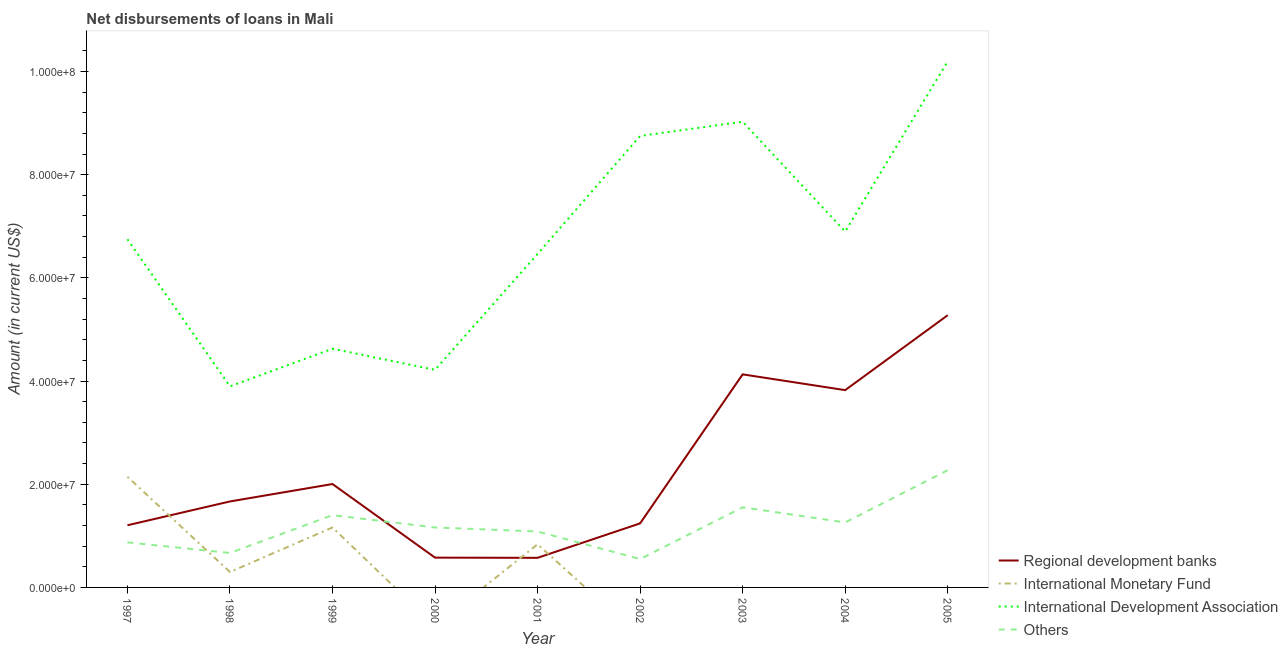How many different coloured lines are there?
Make the answer very short. 4. Does the line corresponding to amount of loan disimbursed by international monetary fund intersect with the line corresponding to amount of loan disimbursed by regional development banks?
Your response must be concise. Yes. What is the amount of loan disimbursed by regional development banks in 2001?
Offer a very short reply. 5.74e+06. Across all years, what is the maximum amount of loan disimbursed by other organisations?
Give a very brief answer. 2.27e+07. Across all years, what is the minimum amount of loan disimbursed by regional development banks?
Keep it short and to the point. 5.74e+06. What is the total amount of loan disimbursed by other organisations in the graph?
Ensure brevity in your answer.  1.08e+08. What is the difference between the amount of loan disimbursed by international development association in 2003 and that in 2004?
Your response must be concise. 2.13e+07. What is the difference between the amount of loan disimbursed by international monetary fund in 2000 and the amount of loan disimbursed by other organisations in 2003?
Offer a very short reply. -1.55e+07. What is the average amount of loan disimbursed by international monetary fund per year?
Offer a very short reply. 4.94e+06. In the year 1999, what is the difference between the amount of loan disimbursed by international monetary fund and amount of loan disimbursed by international development association?
Provide a succinct answer. -3.46e+07. In how many years, is the amount of loan disimbursed by international development association greater than 32000000 US$?
Make the answer very short. 9. What is the ratio of the amount of loan disimbursed by international monetary fund in 1999 to that in 2001?
Your response must be concise. 1.39. What is the difference between the highest and the second highest amount of loan disimbursed by regional development banks?
Provide a short and direct response. 1.15e+07. What is the difference between the highest and the lowest amount of loan disimbursed by regional development banks?
Your answer should be compact. 4.70e+07. Is it the case that in every year, the sum of the amount of loan disimbursed by international monetary fund and amount of loan disimbursed by regional development banks is greater than the sum of amount of loan disimbursed by international development association and amount of loan disimbursed by other organisations?
Your response must be concise. No. Is the amount of loan disimbursed by international development association strictly greater than the amount of loan disimbursed by regional development banks over the years?
Make the answer very short. Yes. How many lines are there?
Give a very brief answer. 4. How many years are there in the graph?
Keep it short and to the point. 9. Are the values on the major ticks of Y-axis written in scientific E-notation?
Offer a very short reply. Yes. Does the graph contain any zero values?
Your answer should be compact. Yes. Does the graph contain grids?
Ensure brevity in your answer.  No. Where does the legend appear in the graph?
Offer a very short reply. Bottom right. What is the title of the graph?
Your answer should be very brief. Net disbursements of loans in Mali. Does "Source data assessment" appear as one of the legend labels in the graph?
Give a very brief answer. No. What is the Amount (in current US$) in Regional development banks in 1997?
Ensure brevity in your answer.  1.21e+07. What is the Amount (in current US$) of International Monetary Fund in 1997?
Offer a terse response. 2.15e+07. What is the Amount (in current US$) in International Development Association in 1997?
Your answer should be very brief. 6.75e+07. What is the Amount (in current US$) of Others in 1997?
Provide a succinct answer. 8.74e+06. What is the Amount (in current US$) of Regional development banks in 1998?
Keep it short and to the point. 1.67e+07. What is the Amount (in current US$) of International Monetary Fund in 1998?
Provide a succinct answer. 2.99e+06. What is the Amount (in current US$) in International Development Association in 1998?
Your answer should be compact. 3.90e+07. What is the Amount (in current US$) in Others in 1998?
Offer a terse response. 6.68e+06. What is the Amount (in current US$) in Regional development banks in 1999?
Offer a very short reply. 2.00e+07. What is the Amount (in current US$) in International Monetary Fund in 1999?
Provide a short and direct response. 1.16e+07. What is the Amount (in current US$) of International Development Association in 1999?
Keep it short and to the point. 4.63e+07. What is the Amount (in current US$) of Others in 1999?
Offer a terse response. 1.40e+07. What is the Amount (in current US$) in Regional development banks in 2000?
Provide a short and direct response. 5.78e+06. What is the Amount (in current US$) of International Monetary Fund in 2000?
Offer a very short reply. 0. What is the Amount (in current US$) in International Development Association in 2000?
Make the answer very short. 4.22e+07. What is the Amount (in current US$) of Others in 2000?
Your response must be concise. 1.16e+07. What is the Amount (in current US$) in Regional development banks in 2001?
Make the answer very short. 5.74e+06. What is the Amount (in current US$) in International Monetary Fund in 2001?
Your response must be concise. 8.37e+06. What is the Amount (in current US$) of International Development Association in 2001?
Your response must be concise. 6.46e+07. What is the Amount (in current US$) in Others in 2001?
Provide a succinct answer. 1.08e+07. What is the Amount (in current US$) in Regional development banks in 2002?
Your answer should be compact. 1.24e+07. What is the Amount (in current US$) of International Monetary Fund in 2002?
Give a very brief answer. 0. What is the Amount (in current US$) of International Development Association in 2002?
Provide a short and direct response. 8.75e+07. What is the Amount (in current US$) in Others in 2002?
Your answer should be very brief. 5.50e+06. What is the Amount (in current US$) of Regional development banks in 2003?
Ensure brevity in your answer.  4.13e+07. What is the Amount (in current US$) of International Development Association in 2003?
Provide a short and direct response. 9.03e+07. What is the Amount (in current US$) of Others in 2003?
Offer a terse response. 1.55e+07. What is the Amount (in current US$) in Regional development banks in 2004?
Give a very brief answer. 3.82e+07. What is the Amount (in current US$) of International Monetary Fund in 2004?
Offer a terse response. 0. What is the Amount (in current US$) of International Development Association in 2004?
Your answer should be compact. 6.90e+07. What is the Amount (in current US$) of Others in 2004?
Provide a short and direct response. 1.26e+07. What is the Amount (in current US$) of Regional development banks in 2005?
Keep it short and to the point. 5.28e+07. What is the Amount (in current US$) in International Monetary Fund in 2005?
Offer a terse response. 0. What is the Amount (in current US$) in International Development Association in 2005?
Your answer should be compact. 1.02e+08. What is the Amount (in current US$) in Others in 2005?
Your response must be concise. 2.27e+07. Across all years, what is the maximum Amount (in current US$) of Regional development banks?
Your response must be concise. 5.28e+07. Across all years, what is the maximum Amount (in current US$) of International Monetary Fund?
Ensure brevity in your answer.  2.15e+07. Across all years, what is the maximum Amount (in current US$) of International Development Association?
Offer a terse response. 1.02e+08. Across all years, what is the maximum Amount (in current US$) of Others?
Your answer should be compact. 2.27e+07. Across all years, what is the minimum Amount (in current US$) of Regional development banks?
Keep it short and to the point. 5.74e+06. Across all years, what is the minimum Amount (in current US$) in International Monetary Fund?
Your answer should be compact. 0. Across all years, what is the minimum Amount (in current US$) in International Development Association?
Make the answer very short. 3.90e+07. Across all years, what is the minimum Amount (in current US$) in Others?
Your response must be concise. 5.50e+06. What is the total Amount (in current US$) of Regional development banks in the graph?
Your response must be concise. 2.05e+08. What is the total Amount (in current US$) of International Monetary Fund in the graph?
Provide a succinct answer. 4.44e+07. What is the total Amount (in current US$) in International Development Association in the graph?
Provide a succinct answer. 6.08e+08. What is the total Amount (in current US$) in Others in the graph?
Ensure brevity in your answer.  1.08e+08. What is the difference between the Amount (in current US$) of Regional development banks in 1997 and that in 1998?
Ensure brevity in your answer.  -4.61e+06. What is the difference between the Amount (in current US$) of International Monetary Fund in 1997 and that in 1998?
Your answer should be very brief. 1.85e+07. What is the difference between the Amount (in current US$) in International Development Association in 1997 and that in 1998?
Offer a terse response. 2.85e+07. What is the difference between the Amount (in current US$) in Others in 1997 and that in 1998?
Your response must be concise. 2.06e+06. What is the difference between the Amount (in current US$) in Regional development banks in 1997 and that in 1999?
Your answer should be compact. -7.99e+06. What is the difference between the Amount (in current US$) in International Monetary Fund in 1997 and that in 1999?
Make the answer very short. 9.83e+06. What is the difference between the Amount (in current US$) of International Development Association in 1997 and that in 1999?
Keep it short and to the point. 2.12e+07. What is the difference between the Amount (in current US$) in Others in 1997 and that in 1999?
Offer a terse response. -5.27e+06. What is the difference between the Amount (in current US$) of Regional development banks in 1997 and that in 2000?
Give a very brief answer. 6.28e+06. What is the difference between the Amount (in current US$) in International Development Association in 1997 and that in 2000?
Your response must be concise. 2.53e+07. What is the difference between the Amount (in current US$) of Others in 1997 and that in 2000?
Offer a terse response. -2.88e+06. What is the difference between the Amount (in current US$) of Regional development banks in 1997 and that in 2001?
Provide a succinct answer. 6.32e+06. What is the difference between the Amount (in current US$) of International Monetary Fund in 1997 and that in 2001?
Provide a succinct answer. 1.31e+07. What is the difference between the Amount (in current US$) of International Development Association in 1997 and that in 2001?
Provide a short and direct response. 2.84e+06. What is the difference between the Amount (in current US$) of Others in 1997 and that in 2001?
Make the answer very short. -2.10e+06. What is the difference between the Amount (in current US$) of Regional development banks in 1997 and that in 2002?
Provide a succinct answer. -3.63e+05. What is the difference between the Amount (in current US$) in International Development Association in 1997 and that in 2002?
Your response must be concise. -2.00e+07. What is the difference between the Amount (in current US$) in Others in 1997 and that in 2002?
Keep it short and to the point. 3.24e+06. What is the difference between the Amount (in current US$) in Regional development banks in 1997 and that in 2003?
Ensure brevity in your answer.  -2.93e+07. What is the difference between the Amount (in current US$) of International Development Association in 1997 and that in 2003?
Offer a terse response. -2.28e+07. What is the difference between the Amount (in current US$) of Others in 1997 and that in 2003?
Provide a short and direct response. -6.79e+06. What is the difference between the Amount (in current US$) in Regional development banks in 1997 and that in 2004?
Provide a succinct answer. -2.62e+07. What is the difference between the Amount (in current US$) of International Development Association in 1997 and that in 2004?
Offer a very short reply. -1.50e+06. What is the difference between the Amount (in current US$) of Others in 1997 and that in 2004?
Offer a terse response. -3.86e+06. What is the difference between the Amount (in current US$) of Regional development banks in 1997 and that in 2005?
Make the answer very short. -4.07e+07. What is the difference between the Amount (in current US$) of International Development Association in 1997 and that in 2005?
Give a very brief answer. -3.45e+07. What is the difference between the Amount (in current US$) in Others in 1997 and that in 2005?
Keep it short and to the point. -1.40e+07. What is the difference between the Amount (in current US$) in Regional development banks in 1998 and that in 1999?
Provide a succinct answer. -3.38e+06. What is the difference between the Amount (in current US$) in International Monetary Fund in 1998 and that in 1999?
Keep it short and to the point. -8.63e+06. What is the difference between the Amount (in current US$) of International Development Association in 1998 and that in 1999?
Make the answer very short. -7.29e+06. What is the difference between the Amount (in current US$) in Others in 1998 and that in 1999?
Your answer should be very brief. -7.33e+06. What is the difference between the Amount (in current US$) in Regional development banks in 1998 and that in 2000?
Your answer should be very brief. 1.09e+07. What is the difference between the Amount (in current US$) of International Development Association in 1998 and that in 2000?
Offer a terse response. -3.20e+06. What is the difference between the Amount (in current US$) of Others in 1998 and that in 2000?
Offer a terse response. -4.94e+06. What is the difference between the Amount (in current US$) in Regional development banks in 1998 and that in 2001?
Keep it short and to the point. 1.09e+07. What is the difference between the Amount (in current US$) in International Monetary Fund in 1998 and that in 2001?
Ensure brevity in your answer.  -5.37e+06. What is the difference between the Amount (in current US$) of International Development Association in 1998 and that in 2001?
Your answer should be very brief. -2.57e+07. What is the difference between the Amount (in current US$) of Others in 1998 and that in 2001?
Provide a succinct answer. -4.16e+06. What is the difference between the Amount (in current US$) of Regional development banks in 1998 and that in 2002?
Your answer should be very brief. 4.25e+06. What is the difference between the Amount (in current US$) in International Development Association in 1998 and that in 2002?
Offer a terse response. -4.85e+07. What is the difference between the Amount (in current US$) of Others in 1998 and that in 2002?
Give a very brief answer. 1.18e+06. What is the difference between the Amount (in current US$) of Regional development banks in 1998 and that in 2003?
Provide a short and direct response. -2.46e+07. What is the difference between the Amount (in current US$) in International Development Association in 1998 and that in 2003?
Offer a terse response. -5.13e+07. What is the difference between the Amount (in current US$) in Others in 1998 and that in 2003?
Provide a short and direct response. -8.85e+06. What is the difference between the Amount (in current US$) in Regional development banks in 1998 and that in 2004?
Ensure brevity in your answer.  -2.16e+07. What is the difference between the Amount (in current US$) in International Development Association in 1998 and that in 2004?
Offer a very short reply. -3.00e+07. What is the difference between the Amount (in current US$) of Others in 1998 and that in 2004?
Your response must be concise. -5.92e+06. What is the difference between the Amount (in current US$) in Regional development banks in 1998 and that in 2005?
Offer a terse response. -3.61e+07. What is the difference between the Amount (in current US$) in International Development Association in 1998 and that in 2005?
Your answer should be compact. -6.30e+07. What is the difference between the Amount (in current US$) in Others in 1998 and that in 2005?
Offer a very short reply. -1.60e+07. What is the difference between the Amount (in current US$) in Regional development banks in 1999 and that in 2000?
Your answer should be very brief. 1.43e+07. What is the difference between the Amount (in current US$) in International Development Association in 1999 and that in 2000?
Offer a very short reply. 4.10e+06. What is the difference between the Amount (in current US$) of Others in 1999 and that in 2000?
Make the answer very short. 2.39e+06. What is the difference between the Amount (in current US$) in Regional development banks in 1999 and that in 2001?
Give a very brief answer. 1.43e+07. What is the difference between the Amount (in current US$) of International Monetary Fund in 1999 and that in 2001?
Provide a short and direct response. 3.26e+06. What is the difference between the Amount (in current US$) of International Development Association in 1999 and that in 2001?
Make the answer very short. -1.84e+07. What is the difference between the Amount (in current US$) of Others in 1999 and that in 2001?
Provide a short and direct response. 3.17e+06. What is the difference between the Amount (in current US$) in Regional development banks in 1999 and that in 2002?
Give a very brief answer. 7.63e+06. What is the difference between the Amount (in current US$) in International Development Association in 1999 and that in 2002?
Your answer should be very brief. -4.12e+07. What is the difference between the Amount (in current US$) in Others in 1999 and that in 2002?
Provide a succinct answer. 8.51e+06. What is the difference between the Amount (in current US$) of Regional development banks in 1999 and that in 2003?
Your response must be concise. -2.13e+07. What is the difference between the Amount (in current US$) in International Development Association in 1999 and that in 2003?
Make the answer very short. -4.40e+07. What is the difference between the Amount (in current US$) in Others in 1999 and that in 2003?
Ensure brevity in your answer.  -1.52e+06. What is the difference between the Amount (in current US$) of Regional development banks in 1999 and that in 2004?
Offer a very short reply. -1.82e+07. What is the difference between the Amount (in current US$) in International Development Association in 1999 and that in 2004?
Give a very brief answer. -2.27e+07. What is the difference between the Amount (in current US$) of Others in 1999 and that in 2004?
Make the answer very short. 1.42e+06. What is the difference between the Amount (in current US$) of Regional development banks in 1999 and that in 2005?
Your answer should be very brief. -3.27e+07. What is the difference between the Amount (in current US$) in International Development Association in 1999 and that in 2005?
Make the answer very short. -5.57e+07. What is the difference between the Amount (in current US$) of Others in 1999 and that in 2005?
Your answer should be compact. -8.71e+06. What is the difference between the Amount (in current US$) in Regional development banks in 2000 and that in 2001?
Provide a short and direct response. 3.80e+04. What is the difference between the Amount (in current US$) in International Development Association in 2000 and that in 2001?
Provide a short and direct response. -2.25e+07. What is the difference between the Amount (in current US$) of Others in 2000 and that in 2001?
Make the answer very short. 7.78e+05. What is the difference between the Amount (in current US$) in Regional development banks in 2000 and that in 2002?
Make the answer very short. -6.64e+06. What is the difference between the Amount (in current US$) in International Development Association in 2000 and that in 2002?
Your answer should be compact. -4.53e+07. What is the difference between the Amount (in current US$) in Others in 2000 and that in 2002?
Ensure brevity in your answer.  6.12e+06. What is the difference between the Amount (in current US$) of Regional development banks in 2000 and that in 2003?
Your answer should be very brief. -3.55e+07. What is the difference between the Amount (in current US$) in International Development Association in 2000 and that in 2003?
Offer a very short reply. -4.81e+07. What is the difference between the Amount (in current US$) in Others in 2000 and that in 2003?
Offer a very short reply. -3.91e+06. What is the difference between the Amount (in current US$) in Regional development banks in 2000 and that in 2004?
Your answer should be compact. -3.25e+07. What is the difference between the Amount (in current US$) of International Development Association in 2000 and that in 2004?
Provide a succinct answer. -2.68e+07. What is the difference between the Amount (in current US$) of Others in 2000 and that in 2004?
Make the answer very short. -9.76e+05. What is the difference between the Amount (in current US$) in Regional development banks in 2000 and that in 2005?
Make the answer very short. -4.70e+07. What is the difference between the Amount (in current US$) in International Development Association in 2000 and that in 2005?
Ensure brevity in your answer.  -5.98e+07. What is the difference between the Amount (in current US$) in Others in 2000 and that in 2005?
Offer a terse response. -1.11e+07. What is the difference between the Amount (in current US$) in Regional development banks in 2001 and that in 2002?
Ensure brevity in your answer.  -6.68e+06. What is the difference between the Amount (in current US$) of International Development Association in 2001 and that in 2002?
Your answer should be compact. -2.29e+07. What is the difference between the Amount (in current US$) of Others in 2001 and that in 2002?
Your answer should be compact. 5.34e+06. What is the difference between the Amount (in current US$) of Regional development banks in 2001 and that in 2003?
Provide a succinct answer. -3.56e+07. What is the difference between the Amount (in current US$) in International Development Association in 2001 and that in 2003?
Your response must be concise. -2.56e+07. What is the difference between the Amount (in current US$) in Others in 2001 and that in 2003?
Your answer should be very brief. -4.69e+06. What is the difference between the Amount (in current US$) of Regional development banks in 2001 and that in 2004?
Keep it short and to the point. -3.25e+07. What is the difference between the Amount (in current US$) in International Development Association in 2001 and that in 2004?
Provide a short and direct response. -4.34e+06. What is the difference between the Amount (in current US$) in Others in 2001 and that in 2004?
Give a very brief answer. -1.75e+06. What is the difference between the Amount (in current US$) of Regional development banks in 2001 and that in 2005?
Your answer should be compact. -4.70e+07. What is the difference between the Amount (in current US$) of International Development Association in 2001 and that in 2005?
Provide a succinct answer. -3.73e+07. What is the difference between the Amount (in current US$) of Others in 2001 and that in 2005?
Keep it short and to the point. -1.19e+07. What is the difference between the Amount (in current US$) of Regional development banks in 2002 and that in 2003?
Offer a very short reply. -2.89e+07. What is the difference between the Amount (in current US$) in International Development Association in 2002 and that in 2003?
Your response must be concise. -2.76e+06. What is the difference between the Amount (in current US$) in Others in 2002 and that in 2003?
Offer a very short reply. -1.00e+07. What is the difference between the Amount (in current US$) of Regional development banks in 2002 and that in 2004?
Your answer should be very brief. -2.58e+07. What is the difference between the Amount (in current US$) in International Development Association in 2002 and that in 2004?
Offer a very short reply. 1.85e+07. What is the difference between the Amount (in current US$) of Others in 2002 and that in 2004?
Provide a short and direct response. -7.10e+06. What is the difference between the Amount (in current US$) of Regional development banks in 2002 and that in 2005?
Offer a very short reply. -4.03e+07. What is the difference between the Amount (in current US$) in International Development Association in 2002 and that in 2005?
Keep it short and to the point. -1.45e+07. What is the difference between the Amount (in current US$) of Others in 2002 and that in 2005?
Ensure brevity in your answer.  -1.72e+07. What is the difference between the Amount (in current US$) in Regional development banks in 2003 and that in 2004?
Offer a very short reply. 3.06e+06. What is the difference between the Amount (in current US$) of International Development Association in 2003 and that in 2004?
Your answer should be compact. 2.13e+07. What is the difference between the Amount (in current US$) of Others in 2003 and that in 2004?
Provide a succinct answer. 2.93e+06. What is the difference between the Amount (in current US$) of Regional development banks in 2003 and that in 2005?
Keep it short and to the point. -1.15e+07. What is the difference between the Amount (in current US$) of International Development Association in 2003 and that in 2005?
Your answer should be compact. -1.17e+07. What is the difference between the Amount (in current US$) in Others in 2003 and that in 2005?
Provide a short and direct response. -7.19e+06. What is the difference between the Amount (in current US$) in Regional development banks in 2004 and that in 2005?
Your response must be concise. -1.45e+07. What is the difference between the Amount (in current US$) of International Development Association in 2004 and that in 2005?
Make the answer very short. -3.30e+07. What is the difference between the Amount (in current US$) of Others in 2004 and that in 2005?
Make the answer very short. -1.01e+07. What is the difference between the Amount (in current US$) in Regional development banks in 1997 and the Amount (in current US$) in International Monetary Fund in 1998?
Your answer should be compact. 9.06e+06. What is the difference between the Amount (in current US$) in Regional development banks in 1997 and the Amount (in current US$) in International Development Association in 1998?
Your answer should be compact. -2.69e+07. What is the difference between the Amount (in current US$) in Regional development banks in 1997 and the Amount (in current US$) in Others in 1998?
Your response must be concise. 5.37e+06. What is the difference between the Amount (in current US$) of International Monetary Fund in 1997 and the Amount (in current US$) of International Development Association in 1998?
Make the answer very short. -1.75e+07. What is the difference between the Amount (in current US$) in International Monetary Fund in 1997 and the Amount (in current US$) in Others in 1998?
Keep it short and to the point. 1.48e+07. What is the difference between the Amount (in current US$) in International Development Association in 1997 and the Amount (in current US$) in Others in 1998?
Provide a short and direct response. 6.08e+07. What is the difference between the Amount (in current US$) in Regional development banks in 1997 and the Amount (in current US$) in International Monetary Fund in 1999?
Ensure brevity in your answer.  4.29e+05. What is the difference between the Amount (in current US$) in Regional development banks in 1997 and the Amount (in current US$) in International Development Association in 1999?
Your answer should be compact. -3.42e+07. What is the difference between the Amount (in current US$) in Regional development banks in 1997 and the Amount (in current US$) in Others in 1999?
Your answer should be compact. -1.96e+06. What is the difference between the Amount (in current US$) in International Monetary Fund in 1997 and the Amount (in current US$) in International Development Association in 1999?
Your response must be concise. -2.48e+07. What is the difference between the Amount (in current US$) of International Monetary Fund in 1997 and the Amount (in current US$) of Others in 1999?
Your answer should be compact. 7.44e+06. What is the difference between the Amount (in current US$) of International Development Association in 1997 and the Amount (in current US$) of Others in 1999?
Make the answer very short. 5.35e+07. What is the difference between the Amount (in current US$) in Regional development banks in 1997 and the Amount (in current US$) in International Development Association in 2000?
Provide a short and direct response. -3.01e+07. What is the difference between the Amount (in current US$) in Regional development banks in 1997 and the Amount (in current US$) in Others in 2000?
Ensure brevity in your answer.  4.31e+05. What is the difference between the Amount (in current US$) of International Monetary Fund in 1997 and the Amount (in current US$) of International Development Association in 2000?
Ensure brevity in your answer.  -2.07e+07. What is the difference between the Amount (in current US$) in International Monetary Fund in 1997 and the Amount (in current US$) in Others in 2000?
Offer a very short reply. 9.83e+06. What is the difference between the Amount (in current US$) of International Development Association in 1997 and the Amount (in current US$) of Others in 2000?
Offer a very short reply. 5.59e+07. What is the difference between the Amount (in current US$) in Regional development banks in 1997 and the Amount (in current US$) in International Monetary Fund in 2001?
Keep it short and to the point. 3.68e+06. What is the difference between the Amount (in current US$) of Regional development banks in 1997 and the Amount (in current US$) of International Development Association in 2001?
Provide a short and direct response. -5.26e+07. What is the difference between the Amount (in current US$) of Regional development banks in 1997 and the Amount (in current US$) of Others in 2001?
Offer a terse response. 1.21e+06. What is the difference between the Amount (in current US$) of International Monetary Fund in 1997 and the Amount (in current US$) of International Development Association in 2001?
Your answer should be compact. -4.32e+07. What is the difference between the Amount (in current US$) of International Monetary Fund in 1997 and the Amount (in current US$) of Others in 2001?
Give a very brief answer. 1.06e+07. What is the difference between the Amount (in current US$) of International Development Association in 1997 and the Amount (in current US$) of Others in 2001?
Your answer should be very brief. 5.66e+07. What is the difference between the Amount (in current US$) in Regional development banks in 1997 and the Amount (in current US$) in International Development Association in 2002?
Your answer should be compact. -7.55e+07. What is the difference between the Amount (in current US$) in Regional development banks in 1997 and the Amount (in current US$) in Others in 2002?
Provide a short and direct response. 6.55e+06. What is the difference between the Amount (in current US$) of International Monetary Fund in 1997 and the Amount (in current US$) of International Development Association in 2002?
Offer a very short reply. -6.61e+07. What is the difference between the Amount (in current US$) in International Monetary Fund in 1997 and the Amount (in current US$) in Others in 2002?
Make the answer very short. 1.60e+07. What is the difference between the Amount (in current US$) of International Development Association in 1997 and the Amount (in current US$) of Others in 2002?
Your response must be concise. 6.20e+07. What is the difference between the Amount (in current US$) in Regional development banks in 1997 and the Amount (in current US$) in International Development Association in 2003?
Your answer should be compact. -7.82e+07. What is the difference between the Amount (in current US$) of Regional development banks in 1997 and the Amount (in current US$) of Others in 2003?
Give a very brief answer. -3.48e+06. What is the difference between the Amount (in current US$) in International Monetary Fund in 1997 and the Amount (in current US$) in International Development Association in 2003?
Provide a short and direct response. -6.88e+07. What is the difference between the Amount (in current US$) of International Monetary Fund in 1997 and the Amount (in current US$) of Others in 2003?
Ensure brevity in your answer.  5.92e+06. What is the difference between the Amount (in current US$) of International Development Association in 1997 and the Amount (in current US$) of Others in 2003?
Give a very brief answer. 5.20e+07. What is the difference between the Amount (in current US$) of Regional development banks in 1997 and the Amount (in current US$) of International Development Association in 2004?
Ensure brevity in your answer.  -5.69e+07. What is the difference between the Amount (in current US$) in Regional development banks in 1997 and the Amount (in current US$) in Others in 2004?
Your response must be concise. -5.45e+05. What is the difference between the Amount (in current US$) in International Monetary Fund in 1997 and the Amount (in current US$) in International Development Association in 2004?
Provide a succinct answer. -4.75e+07. What is the difference between the Amount (in current US$) of International Monetary Fund in 1997 and the Amount (in current US$) of Others in 2004?
Provide a succinct answer. 8.86e+06. What is the difference between the Amount (in current US$) of International Development Association in 1997 and the Amount (in current US$) of Others in 2004?
Ensure brevity in your answer.  5.49e+07. What is the difference between the Amount (in current US$) of Regional development banks in 1997 and the Amount (in current US$) of International Development Association in 2005?
Ensure brevity in your answer.  -8.99e+07. What is the difference between the Amount (in current US$) in Regional development banks in 1997 and the Amount (in current US$) in Others in 2005?
Your response must be concise. -1.07e+07. What is the difference between the Amount (in current US$) of International Monetary Fund in 1997 and the Amount (in current US$) of International Development Association in 2005?
Your response must be concise. -8.05e+07. What is the difference between the Amount (in current US$) in International Monetary Fund in 1997 and the Amount (in current US$) in Others in 2005?
Your answer should be very brief. -1.27e+06. What is the difference between the Amount (in current US$) in International Development Association in 1997 and the Amount (in current US$) in Others in 2005?
Your answer should be compact. 4.48e+07. What is the difference between the Amount (in current US$) in Regional development banks in 1998 and the Amount (in current US$) in International Monetary Fund in 1999?
Offer a terse response. 5.04e+06. What is the difference between the Amount (in current US$) in Regional development banks in 1998 and the Amount (in current US$) in International Development Association in 1999?
Keep it short and to the point. -2.96e+07. What is the difference between the Amount (in current US$) in Regional development banks in 1998 and the Amount (in current US$) in Others in 1999?
Offer a very short reply. 2.65e+06. What is the difference between the Amount (in current US$) of International Monetary Fund in 1998 and the Amount (in current US$) of International Development Association in 1999?
Provide a short and direct response. -4.33e+07. What is the difference between the Amount (in current US$) in International Monetary Fund in 1998 and the Amount (in current US$) in Others in 1999?
Keep it short and to the point. -1.10e+07. What is the difference between the Amount (in current US$) of International Development Association in 1998 and the Amount (in current US$) of Others in 1999?
Provide a succinct answer. 2.50e+07. What is the difference between the Amount (in current US$) in Regional development banks in 1998 and the Amount (in current US$) in International Development Association in 2000?
Your answer should be compact. -2.55e+07. What is the difference between the Amount (in current US$) of Regional development banks in 1998 and the Amount (in current US$) of Others in 2000?
Your answer should be very brief. 5.04e+06. What is the difference between the Amount (in current US$) of International Monetary Fund in 1998 and the Amount (in current US$) of International Development Association in 2000?
Ensure brevity in your answer.  -3.92e+07. What is the difference between the Amount (in current US$) in International Monetary Fund in 1998 and the Amount (in current US$) in Others in 2000?
Offer a terse response. -8.63e+06. What is the difference between the Amount (in current US$) in International Development Association in 1998 and the Amount (in current US$) in Others in 2000?
Your response must be concise. 2.74e+07. What is the difference between the Amount (in current US$) in Regional development banks in 1998 and the Amount (in current US$) in International Monetary Fund in 2001?
Offer a very short reply. 8.30e+06. What is the difference between the Amount (in current US$) of Regional development banks in 1998 and the Amount (in current US$) of International Development Association in 2001?
Your response must be concise. -4.80e+07. What is the difference between the Amount (in current US$) in Regional development banks in 1998 and the Amount (in current US$) in Others in 2001?
Make the answer very short. 5.82e+06. What is the difference between the Amount (in current US$) of International Monetary Fund in 1998 and the Amount (in current US$) of International Development Association in 2001?
Offer a very short reply. -6.17e+07. What is the difference between the Amount (in current US$) in International Monetary Fund in 1998 and the Amount (in current US$) in Others in 2001?
Provide a short and direct response. -7.85e+06. What is the difference between the Amount (in current US$) of International Development Association in 1998 and the Amount (in current US$) of Others in 2001?
Offer a terse response. 2.81e+07. What is the difference between the Amount (in current US$) of Regional development banks in 1998 and the Amount (in current US$) of International Development Association in 2002?
Offer a terse response. -7.08e+07. What is the difference between the Amount (in current US$) of Regional development banks in 1998 and the Amount (in current US$) of Others in 2002?
Your answer should be very brief. 1.12e+07. What is the difference between the Amount (in current US$) of International Monetary Fund in 1998 and the Amount (in current US$) of International Development Association in 2002?
Your response must be concise. -8.45e+07. What is the difference between the Amount (in current US$) in International Monetary Fund in 1998 and the Amount (in current US$) in Others in 2002?
Provide a short and direct response. -2.51e+06. What is the difference between the Amount (in current US$) of International Development Association in 1998 and the Amount (in current US$) of Others in 2002?
Make the answer very short. 3.35e+07. What is the difference between the Amount (in current US$) of Regional development banks in 1998 and the Amount (in current US$) of International Development Association in 2003?
Provide a short and direct response. -7.36e+07. What is the difference between the Amount (in current US$) of Regional development banks in 1998 and the Amount (in current US$) of Others in 2003?
Your response must be concise. 1.14e+06. What is the difference between the Amount (in current US$) of International Monetary Fund in 1998 and the Amount (in current US$) of International Development Association in 2003?
Your answer should be compact. -8.73e+07. What is the difference between the Amount (in current US$) in International Monetary Fund in 1998 and the Amount (in current US$) in Others in 2003?
Provide a succinct answer. -1.25e+07. What is the difference between the Amount (in current US$) in International Development Association in 1998 and the Amount (in current US$) in Others in 2003?
Give a very brief answer. 2.34e+07. What is the difference between the Amount (in current US$) of Regional development banks in 1998 and the Amount (in current US$) of International Development Association in 2004?
Make the answer very short. -5.23e+07. What is the difference between the Amount (in current US$) of Regional development banks in 1998 and the Amount (in current US$) of Others in 2004?
Offer a very short reply. 4.07e+06. What is the difference between the Amount (in current US$) of International Monetary Fund in 1998 and the Amount (in current US$) of International Development Association in 2004?
Keep it short and to the point. -6.60e+07. What is the difference between the Amount (in current US$) of International Monetary Fund in 1998 and the Amount (in current US$) of Others in 2004?
Offer a very short reply. -9.60e+06. What is the difference between the Amount (in current US$) of International Development Association in 1998 and the Amount (in current US$) of Others in 2004?
Make the answer very short. 2.64e+07. What is the difference between the Amount (in current US$) of Regional development banks in 1998 and the Amount (in current US$) of International Development Association in 2005?
Make the answer very short. -8.53e+07. What is the difference between the Amount (in current US$) of Regional development banks in 1998 and the Amount (in current US$) of Others in 2005?
Provide a succinct answer. -6.05e+06. What is the difference between the Amount (in current US$) of International Monetary Fund in 1998 and the Amount (in current US$) of International Development Association in 2005?
Give a very brief answer. -9.90e+07. What is the difference between the Amount (in current US$) in International Monetary Fund in 1998 and the Amount (in current US$) in Others in 2005?
Ensure brevity in your answer.  -1.97e+07. What is the difference between the Amount (in current US$) of International Development Association in 1998 and the Amount (in current US$) of Others in 2005?
Your response must be concise. 1.63e+07. What is the difference between the Amount (in current US$) in Regional development banks in 1999 and the Amount (in current US$) in International Development Association in 2000?
Your response must be concise. -2.21e+07. What is the difference between the Amount (in current US$) of Regional development banks in 1999 and the Amount (in current US$) of Others in 2000?
Offer a terse response. 8.42e+06. What is the difference between the Amount (in current US$) of International Monetary Fund in 1999 and the Amount (in current US$) of International Development Association in 2000?
Provide a succinct answer. -3.06e+07. What is the difference between the Amount (in current US$) in International Development Association in 1999 and the Amount (in current US$) in Others in 2000?
Make the answer very short. 3.46e+07. What is the difference between the Amount (in current US$) in Regional development banks in 1999 and the Amount (in current US$) in International Monetary Fund in 2001?
Make the answer very short. 1.17e+07. What is the difference between the Amount (in current US$) in Regional development banks in 1999 and the Amount (in current US$) in International Development Association in 2001?
Offer a terse response. -4.46e+07. What is the difference between the Amount (in current US$) in Regional development banks in 1999 and the Amount (in current US$) in Others in 2001?
Provide a short and direct response. 9.20e+06. What is the difference between the Amount (in current US$) of International Monetary Fund in 1999 and the Amount (in current US$) of International Development Association in 2001?
Make the answer very short. -5.30e+07. What is the difference between the Amount (in current US$) of International Monetary Fund in 1999 and the Amount (in current US$) of Others in 2001?
Keep it short and to the point. 7.80e+05. What is the difference between the Amount (in current US$) in International Development Association in 1999 and the Amount (in current US$) in Others in 2001?
Provide a short and direct response. 3.54e+07. What is the difference between the Amount (in current US$) in Regional development banks in 1999 and the Amount (in current US$) in International Development Association in 2002?
Keep it short and to the point. -6.75e+07. What is the difference between the Amount (in current US$) in Regional development banks in 1999 and the Amount (in current US$) in Others in 2002?
Your answer should be compact. 1.45e+07. What is the difference between the Amount (in current US$) in International Monetary Fund in 1999 and the Amount (in current US$) in International Development Association in 2002?
Offer a terse response. -7.59e+07. What is the difference between the Amount (in current US$) in International Monetary Fund in 1999 and the Amount (in current US$) in Others in 2002?
Your answer should be very brief. 6.12e+06. What is the difference between the Amount (in current US$) of International Development Association in 1999 and the Amount (in current US$) of Others in 2002?
Provide a succinct answer. 4.08e+07. What is the difference between the Amount (in current US$) in Regional development banks in 1999 and the Amount (in current US$) in International Development Association in 2003?
Make the answer very short. -7.02e+07. What is the difference between the Amount (in current US$) of Regional development banks in 1999 and the Amount (in current US$) of Others in 2003?
Keep it short and to the point. 4.51e+06. What is the difference between the Amount (in current US$) of International Monetary Fund in 1999 and the Amount (in current US$) of International Development Association in 2003?
Your response must be concise. -7.86e+07. What is the difference between the Amount (in current US$) in International Monetary Fund in 1999 and the Amount (in current US$) in Others in 2003?
Your answer should be compact. -3.91e+06. What is the difference between the Amount (in current US$) in International Development Association in 1999 and the Amount (in current US$) in Others in 2003?
Provide a short and direct response. 3.07e+07. What is the difference between the Amount (in current US$) in Regional development banks in 1999 and the Amount (in current US$) in International Development Association in 2004?
Offer a terse response. -4.89e+07. What is the difference between the Amount (in current US$) of Regional development banks in 1999 and the Amount (in current US$) of Others in 2004?
Your answer should be compact. 7.45e+06. What is the difference between the Amount (in current US$) of International Monetary Fund in 1999 and the Amount (in current US$) of International Development Association in 2004?
Keep it short and to the point. -5.74e+07. What is the difference between the Amount (in current US$) in International Monetary Fund in 1999 and the Amount (in current US$) in Others in 2004?
Ensure brevity in your answer.  -9.74e+05. What is the difference between the Amount (in current US$) in International Development Association in 1999 and the Amount (in current US$) in Others in 2004?
Provide a short and direct response. 3.37e+07. What is the difference between the Amount (in current US$) of Regional development banks in 1999 and the Amount (in current US$) of International Development Association in 2005?
Give a very brief answer. -8.19e+07. What is the difference between the Amount (in current US$) in Regional development banks in 1999 and the Amount (in current US$) in Others in 2005?
Make the answer very short. -2.68e+06. What is the difference between the Amount (in current US$) in International Monetary Fund in 1999 and the Amount (in current US$) in International Development Association in 2005?
Give a very brief answer. -9.04e+07. What is the difference between the Amount (in current US$) in International Monetary Fund in 1999 and the Amount (in current US$) in Others in 2005?
Your answer should be very brief. -1.11e+07. What is the difference between the Amount (in current US$) in International Development Association in 1999 and the Amount (in current US$) in Others in 2005?
Make the answer very short. 2.36e+07. What is the difference between the Amount (in current US$) of Regional development banks in 2000 and the Amount (in current US$) of International Monetary Fund in 2001?
Your answer should be very brief. -2.59e+06. What is the difference between the Amount (in current US$) of Regional development banks in 2000 and the Amount (in current US$) of International Development Association in 2001?
Your answer should be very brief. -5.89e+07. What is the difference between the Amount (in current US$) of Regional development banks in 2000 and the Amount (in current US$) of Others in 2001?
Keep it short and to the point. -5.07e+06. What is the difference between the Amount (in current US$) of International Development Association in 2000 and the Amount (in current US$) of Others in 2001?
Provide a succinct answer. 3.13e+07. What is the difference between the Amount (in current US$) of Regional development banks in 2000 and the Amount (in current US$) of International Development Association in 2002?
Offer a terse response. -8.17e+07. What is the difference between the Amount (in current US$) in Regional development banks in 2000 and the Amount (in current US$) in Others in 2002?
Provide a short and direct response. 2.74e+05. What is the difference between the Amount (in current US$) of International Development Association in 2000 and the Amount (in current US$) of Others in 2002?
Make the answer very short. 3.67e+07. What is the difference between the Amount (in current US$) of Regional development banks in 2000 and the Amount (in current US$) of International Development Association in 2003?
Your response must be concise. -8.45e+07. What is the difference between the Amount (in current US$) of Regional development banks in 2000 and the Amount (in current US$) of Others in 2003?
Make the answer very short. -9.76e+06. What is the difference between the Amount (in current US$) in International Development Association in 2000 and the Amount (in current US$) in Others in 2003?
Ensure brevity in your answer.  2.66e+07. What is the difference between the Amount (in current US$) in Regional development banks in 2000 and the Amount (in current US$) in International Development Association in 2004?
Make the answer very short. -6.32e+07. What is the difference between the Amount (in current US$) of Regional development banks in 2000 and the Amount (in current US$) of Others in 2004?
Keep it short and to the point. -6.82e+06. What is the difference between the Amount (in current US$) of International Development Association in 2000 and the Amount (in current US$) of Others in 2004?
Provide a succinct answer. 2.96e+07. What is the difference between the Amount (in current US$) in Regional development banks in 2000 and the Amount (in current US$) in International Development Association in 2005?
Provide a succinct answer. -9.62e+07. What is the difference between the Amount (in current US$) of Regional development banks in 2000 and the Amount (in current US$) of Others in 2005?
Make the answer very short. -1.69e+07. What is the difference between the Amount (in current US$) in International Development Association in 2000 and the Amount (in current US$) in Others in 2005?
Provide a short and direct response. 1.95e+07. What is the difference between the Amount (in current US$) of Regional development banks in 2001 and the Amount (in current US$) of International Development Association in 2002?
Offer a very short reply. -8.18e+07. What is the difference between the Amount (in current US$) in Regional development banks in 2001 and the Amount (in current US$) in Others in 2002?
Make the answer very short. 2.36e+05. What is the difference between the Amount (in current US$) in International Monetary Fund in 2001 and the Amount (in current US$) in International Development Association in 2002?
Provide a succinct answer. -7.91e+07. What is the difference between the Amount (in current US$) of International Monetary Fund in 2001 and the Amount (in current US$) of Others in 2002?
Provide a succinct answer. 2.87e+06. What is the difference between the Amount (in current US$) in International Development Association in 2001 and the Amount (in current US$) in Others in 2002?
Ensure brevity in your answer.  5.91e+07. What is the difference between the Amount (in current US$) of Regional development banks in 2001 and the Amount (in current US$) of International Development Association in 2003?
Your response must be concise. -8.45e+07. What is the difference between the Amount (in current US$) of Regional development banks in 2001 and the Amount (in current US$) of Others in 2003?
Your answer should be very brief. -9.79e+06. What is the difference between the Amount (in current US$) of International Monetary Fund in 2001 and the Amount (in current US$) of International Development Association in 2003?
Make the answer very short. -8.19e+07. What is the difference between the Amount (in current US$) of International Monetary Fund in 2001 and the Amount (in current US$) of Others in 2003?
Your response must be concise. -7.16e+06. What is the difference between the Amount (in current US$) in International Development Association in 2001 and the Amount (in current US$) in Others in 2003?
Keep it short and to the point. 4.91e+07. What is the difference between the Amount (in current US$) of Regional development banks in 2001 and the Amount (in current US$) of International Development Association in 2004?
Your response must be concise. -6.32e+07. What is the difference between the Amount (in current US$) of Regional development banks in 2001 and the Amount (in current US$) of Others in 2004?
Your answer should be very brief. -6.86e+06. What is the difference between the Amount (in current US$) of International Monetary Fund in 2001 and the Amount (in current US$) of International Development Association in 2004?
Your answer should be very brief. -6.06e+07. What is the difference between the Amount (in current US$) of International Monetary Fund in 2001 and the Amount (in current US$) of Others in 2004?
Offer a terse response. -4.23e+06. What is the difference between the Amount (in current US$) of International Development Association in 2001 and the Amount (in current US$) of Others in 2004?
Provide a succinct answer. 5.20e+07. What is the difference between the Amount (in current US$) of Regional development banks in 2001 and the Amount (in current US$) of International Development Association in 2005?
Your answer should be very brief. -9.63e+07. What is the difference between the Amount (in current US$) of Regional development banks in 2001 and the Amount (in current US$) of Others in 2005?
Your answer should be compact. -1.70e+07. What is the difference between the Amount (in current US$) in International Monetary Fund in 2001 and the Amount (in current US$) in International Development Association in 2005?
Provide a short and direct response. -9.36e+07. What is the difference between the Amount (in current US$) of International Monetary Fund in 2001 and the Amount (in current US$) of Others in 2005?
Give a very brief answer. -1.44e+07. What is the difference between the Amount (in current US$) of International Development Association in 2001 and the Amount (in current US$) of Others in 2005?
Ensure brevity in your answer.  4.19e+07. What is the difference between the Amount (in current US$) of Regional development banks in 2002 and the Amount (in current US$) of International Development Association in 2003?
Your response must be concise. -7.79e+07. What is the difference between the Amount (in current US$) in Regional development banks in 2002 and the Amount (in current US$) in Others in 2003?
Your response must be concise. -3.12e+06. What is the difference between the Amount (in current US$) of International Development Association in 2002 and the Amount (in current US$) of Others in 2003?
Make the answer very short. 7.20e+07. What is the difference between the Amount (in current US$) in Regional development banks in 2002 and the Amount (in current US$) in International Development Association in 2004?
Give a very brief answer. -5.66e+07. What is the difference between the Amount (in current US$) in Regional development banks in 2002 and the Amount (in current US$) in Others in 2004?
Offer a very short reply. -1.82e+05. What is the difference between the Amount (in current US$) in International Development Association in 2002 and the Amount (in current US$) in Others in 2004?
Your response must be concise. 7.49e+07. What is the difference between the Amount (in current US$) in Regional development banks in 2002 and the Amount (in current US$) in International Development Association in 2005?
Your answer should be very brief. -8.96e+07. What is the difference between the Amount (in current US$) in Regional development banks in 2002 and the Amount (in current US$) in Others in 2005?
Offer a terse response. -1.03e+07. What is the difference between the Amount (in current US$) of International Development Association in 2002 and the Amount (in current US$) of Others in 2005?
Your response must be concise. 6.48e+07. What is the difference between the Amount (in current US$) in Regional development banks in 2003 and the Amount (in current US$) in International Development Association in 2004?
Your answer should be very brief. -2.77e+07. What is the difference between the Amount (in current US$) in Regional development banks in 2003 and the Amount (in current US$) in Others in 2004?
Make the answer very short. 2.87e+07. What is the difference between the Amount (in current US$) of International Development Association in 2003 and the Amount (in current US$) of Others in 2004?
Your answer should be compact. 7.77e+07. What is the difference between the Amount (in current US$) in Regional development banks in 2003 and the Amount (in current US$) in International Development Association in 2005?
Offer a terse response. -6.07e+07. What is the difference between the Amount (in current US$) in Regional development banks in 2003 and the Amount (in current US$) in Others in 2005?
Give a very brief answer. 1.86e+07. What is the difference between the Amount (in current US$) of International Development Association in 2003 and the Amount (in current US$) of Others in 2005?
Your response must be concise. 6.76e+07. What is the difference between the Amount (in current US$) in Regional development banks in 2004 and the Amount (in current US$) in International Development Association in 2005?
Make the answer very short. -6.37e+07. What is the difference between the Amount (in current US$) in Regional development banks in 2004 and the Amount (in current US$) in Others in 2005?
Your answer should be very brief. 1.55e+07. What is the difference between the Amount (in current US$) in International Development Association in 2004 and the Amount (in current US$) in Others in 2005?
Offer a terse response. 4.63e+07. What is the average Amount (in current US$) in Regional development banks per year?
Keep it short and to the point. 2.28e+07. What is the average Amount (in current US$) of International Monetary Fund per year?
Your response must be concise. 4.94e+06. What is the average Amount (in current US$) in International Development Association per year?
Your answer should be very brief. 6.76e+07. What is the average Amount (in current US$) in Others per year?
Provide a succinct answer. 1.20e+07. In the year 1997, what is the difference between the Amount (in current US$) in Regional development banks and Amount (in current US$) in International Monetary Fund?
Ensure brevity in your answer.  -9.40e+06. In the year 1997, what is the difference between the Amount (in current US$) in Regional development banks and Amount (in current US$) in International Development Association?
Give a very brief answer. -5.54e+07. In the year 1997, what is the difference between the Amount (in current US$) of Regional development banks and Amount (in current US$) of Others?
Your answer should be compact. 3.31e+06. In the year 1997, what is the difference between the Amount (in current US$) of International Monetary Fund and Amount (in current US$) of International Development Association?
Your answer should be compact. -4.60e+07. In the year 1997, what is the difference between the Amount (in current US$) in International Monetary Fund and Amount (in current US$) in Others?
Ensure brevity in your answer.  1.27e+07. In the year 1997, what is the difference between the Amount (in current US$) of International Development Association and Amount (in current US$) of Others?
Keep it short and to the point. 5.88e+07. In the year 1998, what is the difference between the Amount (in current US$) of Regional development banks and Amount (in current US$) of International Monetary Fund?
Make the answer very short. 1.37e+07. In the year 1998, what is the difference between the Amount (in current US$) in Regional development banks and Amount (in current US$) in International Development Association?
Provide a succinct answer. -2.23e+07. In the year 1998, what is the difference between the Amount (in current US$) in Regional development banks and Amount (in current US$) in Others?
Your answer should be compact. 9.99e+06. In the year 1998, what is the difference between the Amount (in current US$) in International Monetary Fund and Amount (in current US$) in International Development Association?
Your response must be concise. -3.60e+07. In the year 1998, what is the difference between the Amount (in current US$) in International Monetary Fund and Amount (in current US$) in Others?
Offer a very short reply. -3.68e+06. In the year 1998, what is the difference between the Amount (in current US$) of International Development Association and Amount (in current US$) of Others?
Your answer should be very brief. 3.23e+07. In the year 1999, what is the difference between the Amount (in current US$) in Regional development banks and Amount (in current US$) in International Monetary Fund?
Keep it short and to the point. 8.42e+06. In the year 1999, what is the difference between the Amount (in current US$) of Regional development banks and Amount (in current US$) of International Development Association?
Ensure brevity in your answer.  -2.62e+07. In the year 1999, what is the difference between the Amount (in current US$) of Regional development banks and Amount (in current US$) of Others?
Offer a very short reply. 6.03e+06. In the year 1999, what is the difference between the Amount (in current US$) of International Monetary Fund and Amount (in current US$) of International Development Association?
Your answer should be compact. -3.46e+07. In the year 1999, what is the difference between the Amount (in current US$) in International Monetary Fund and Amount (in current US$) in Others?
Make the answer very short. -2.39e+06. In the year 1999, what is the difference between the Amount (in current US$) in International Development Association and Amount (in current US$) in Others?
Ensure brevity in your answer.  3.23e+07. In the year 2000, what is the difference between the Amount (in current US$) of Regional development banks and Amount (in current US$) of International Development Association?
Provide a short and direct response. -3.64e+07. In the year 2000, what is the difference between the Amount (in current US$) in Regional development banks and Amount (in current US$) in Others?
Your answer should be compact. -5.85e+06. In the year 2000, what is the difference between the Amount (in current US$) of International Development Association and Amount (in current US$) of Others?
Your answer should be very brief. 3.06e+07. In the year 2001, what is the difference between the Amount (in current US$) of Regional development banks and Amount (in current US$) of International Monetary Fund?
Offer a terse response. -2.63e+06. In the year 2001, what is the difference between the Amount (in current US$) in Regional development banks and Amount (in current US$) in International Development Association?
Give a very brief answer. -5.89e+07. In the year 2001, what is the difference between the Amount (in current US$) in Regional development banks and Amount (in current US$) in Others?
Keep it short and to the point. -5.11e+06. In the year 2001, what is the difference between the Amount (in current US$) in International Monetary Fund and Amount (in current US$) in International Development Association?
Make the answer very short. -5.63e+07. In the year 2001, what is the difference between the Amount (in current US$) in International Monetary Fund and Amount (in current US$) in Others?
Make the answer very short. -2.48e+06. In the year 2001, what is the difference between the Amount (in current US$) of International Development Association and Amount (in current US$) of Others?
Provide a short and direct response. 5.38e+07. In the year 2002, what is the difference between the Amount (in current US$) of Regional development banks and Amount (in current US$) of International Development Association?
Keep it short and to the point. -7.51e+07. In the year 2002, what is the difference between the Amount (in current US$) of Regional development banks and Amount (in current US$) of Others?
Your answer should be compact. 6.91e+06. In the year 2002, what is the difference between the Amount (in current US$) of International Development Association and Amount (in current US$) of Others?
Ensure brevity in your answer.  8.20e+07. In the year 2003, what is the difference between the Amount (in current US$) in Regional development banks and Amount (in current US$) in International Development Association?
Keep it short and to the point. -4.90e+07. In the year 2003, what is the difference between the Amount (in current US$) in Regional development banks and Amount (in current US$) in Others?
Give a very brief answer. 2.58e+07. In the year 2003, what is the difference between the Amount (in current US$) of International Development Association and Amount (in current US$) of Others?
Offer a terse response. 7.47e+07. In the year 2004, what is the difference between the Amount (in current US$) of Regional development banks and Amount (in current US$) of International Development Association?
Provide a succinct answer. -3.07e+07. In the year 2004, what is the difference between the Amount (in current US$) in Regional development banks and Amount (in current US$) in Others?
Keep it short and to the point. 2.56e+07. In the year 2004, what is the difference between the Amount (in current US$) in International Development Association and Amount (in current US$) in Others?
Make the answer very short. 5.64e+07. In the year 2005, what is the difference between the Amount (in current US$) of Regional development banks and Amount (in current US$) of International Development Association?
Ensure brevity in your answer.  -4.92e+07. In the year 2005, what is the difference between the Amount (in current US$) in Regional development banks and Amount (in current US$) in Others?
Your answer should be very brief. 3.00e+07. In the year 2005, what is the difference between the Amount (in current US$) of International Development Association and Amount (in current US$) of Others?
Offer a very short reply. 7.93e+07. What is the ratio of the Amount (in current US$) of Regional development banks in 1997 to that in 1998?
Your response must be concise. 0.72. What is the ratio of the Amount (in current US$) of International Monetary Fund in 1997 to that in 1998?
Keep it short and to the point. 7.17. What is the ratio of the Amount (in current US$) of International Development Association in 1997 to that in 1998?
Ensure brevity in your answer.  1.73. What is the ratio of the Amount (in current US$) in Others in 1997 to that in 1998?
Ensure brevity in your answer.  1.31. What is the ratio of the Amount (in current US$) in Regional development banks in 1997 to that in 1999?
Offer a terse response. 0.6. What is the ratio of the Amount (in current US$) of International Monetary Fund in 1997 to that in 1999?
Provide a short and direct response. 1.85. What is the ratio of the Amount (in current US$) in International Development Association in 1997 to that in 1999?
Provide a short and direct response. 1.46. What is the ratio of the Amount (in current US$) in Others in 1997 to that in 1999?
Keep it short and to the point. 0.62. What is the ratio of the Amount (in current US$) in Regional development banks in 1997 to that in 2000?
Your response must be concise. 2.09. What is the ratio of the Amount (in current US$) in International Development Association in 1997 to that in 2000?
Offer a terse response. 1.6. What is the ratio of the Amount (in current US$) of Others in 1997 to that in 2000?
Your answer should be compact. 0.75. What is the ratio of the Amount (in current US$) of Regional development banks in 1997 to that in 2001?
Provide a succinct answer. 2.1. What is the ratio of the Amount (in current US$) of International Monetary Fund in 1997 to that in 2001?
Offer a terse response. 2.56. What is the ratio of the Amount (in current US$) of International Development Association in 1997 to that in 2001?
Provide a short and direct response. 1.04. What is the ratio of the Amount (in current US$) of Others in 1997 to that in 2001?
Provide a succinct answer. 0.81. What is the ratio of the Amount (in current US$) of Regional development banks in 1997 to that in 2002?
Give a very brief answer. 0.97. What is the ratio of the Amount (in current US$) of International Development Association in 1997 to that in 2002?
Make the answer very short. 0.77. What is the ratio of the Amount (in current US$) in Others in 1997 to that in 2002?
Offer a terse response. 1.59. What is the ratio of the Amount (in current US$) of Regional development banks in 1997 to that in 2003?
Your answer should be compact. 0.29. What is the ratio of the Amount (in current US$) of International Development Association in 1997 to that in 2003?
Offer a terse response. 0.75. What is the ratio of the Amount (in current US$) in Others in 1997 to that in 2003?
Your answer should be compact. 0.56. What is the ratio of the Amount (in current US$) of Regional development banks in 1997 to that in 2004?
Your response must be concise. 0.32. What is the ratio of the Amount (in current US$) of International Development Association in 1997 to that in 2004?
Make the answer very short. 0.98. What is the ratio of the Amount (in current US$) of Others in 1997 to that in 2004?
Offer a terse response. 0.69. What is the ratio of the Amount (in current US$) in Regional development banks in 1997 to that in 2005?
Your answer should be very brief. 0.23. What is the ratio of the Amount (in current US$) in International Development Association in 1997 to that in 2005?
Your response must be concise. 0.66. What is the ratio of the Amount (in current US$) in Others in 1997 to that in 2005?
Give a very brief answer. 0.38. What is the ratio of the Amount (in current US$) in Regional development banks in 1998 to that in 1999?
Keep it short and to the point. 0.83. What is the ratio of the Amount (in current US$) of International Monetary Fund in 1998 to that in 1999?
Provide a succinct answer. 0.26. What is the ratio of the Amount (in current US$) of International Development Association in 1998 to that in 1999?
Give a very brief answer. 0.84. What is the ratio of the Amount (in current US$) of Others in 1998 to that in 1999?
Offer a terse response. 0.48. What is the ratio of the Amount (in current US$) of Regional development banks in 1998 to that in 2000?
Provide a short and direct response. 2.89. What is the ratio of the Amount (in current US$) in International Development Association in 1998 to that in 2000?
Your answer should be compact. 0.92. What is the ratio of the Amount (in current US$) in Others in 1998 to that in 2000?
Give a very brief answer. 0.57. What is the ratio of the Amount (in current US$) of Regional development banks in 1998 to that in 2001?
Make the answer very short. 2.9. What is the ratio of the Amount (in current US$) of International Monetary Fund in 1998 to that in 2001?
Make the answer very short. 0.36. What is the ratio of the Amount (in current US$) in International Development Association in 1998 to that in 2001?
Offer a very short reply. 0.6. What is the ratio of the Amount (in current US$) of Others in 1998 to that in 2001?
Offer a terse response. 0.62. What is the ratio of the Amount (in current US$) of Regional development banks in 1998 to that in 2002?
Provide a short and direct response. 1.34. What is the ratio of the Amount (in current US$) in International Development Association in 1998 to that in 2002?
Your response must be concise. 0.45. What is the ratio of the Amount (in current US$) in Others in 1998 to that in 2002?
Ensure brevity in your answer.  1.21. What is the ratio of the Amount (in current US$) in Regional development banks in 1998 to that in 2003?
Provide a short and direct response. 0.4. What is the ratio of the Amount (in current US$) of International Development Association in 1998 to that in 2003?
Your response must be concise. 0.43. What is the ratio of the Amount (in current US$) in Others in 1998 to that in 2003?
Offer a terse response. 0.43. What is the ratio of the Amount (in current US$) of Regional development banks in 1998 to that in 2004?
Your response must be concise. 0.44. What is the ratio of the Amount (in current US$) of International Development Association in 1998 to that in 2004?
Provide a succinct answer. 0.56. What is the ratio of the Amount (in current US$) of Others in 1998 to that in 2004?
Ensure brevity in your answer.  0.53. What is the ratio of the Amount (in current US$) in Regional development banks in 1998 to that in 2005?
Provide a short and direct response. 0.32. What is the ratio of the Amount (in current US$) of International Development Association in 1998 to that in 2005?
Your response must be concise. 0.38. What is the ratio of the Amount (in current US$) of Others in 1998 to that in 2005?
Offer a very short reply. 0.29. What is the ratio of the Amount (in current US$) of Regional development banks in 1999 to that in 2000?
Your response must be concise. 3.47. What is the ratio of the Amount (in current US$) of International Development Association in 1999 to that in 2000?
Your answer should be very brief. 1.1. What is the ratio of the Amount (in current US$) of Others in 1999 to that in 2000?
Provide a succinct answer. 1.21. What is the ratio of the Amount (in current US$) in Regional development banks in 1999 to that in 2001?
Provide a short and direct response. 3.49. What is the ratio of the Amount (in current US$) in International Monetary Fund in 1999 to that in 2001?
Keep it short and to the point. 1.39. What is the ratio of the Amount (in current US$) in International Development Association in 1999 to that in 2001?
Make the answer very short. 0.72. What is the ratio of the Amount (in current US$) of Others in 1999 to that in 2001?
Provide a succinct answer. 1.29. What is the ratio of the Amount (in current US$) of Regional development banks in 1999 to that in 2002?
Your answer should be compact. 1.61. What is the ratio of the Amount (in current US$) in International Development Association in 1999 to that in 2002?
Your answer should be compact. 0.53. What is the ratio of the Amount (in current US$) of Others in 1999 to that in 2002?
Give a very brief answer. 2.55. What is the ratio of the Amount (in current US$) of Regional development banks in 1999 to that in 2003?
Your response must be concise. 0.49. What is the ratio of the Amount (in current US$) in International Development Association in 1999 to that in 2003?
Make the answer very short. 0.51. What is the ratio of the Amount (in current US$) of Others in 1999 to that in 2003?
Keep it short and to the point. 0.9. What is the ratio of the Amount (in current US$) of Regional development banks in 1999 to that in 2004?
Give a very brief answer. 0.52. What is the ratio of the Amount (in current US$) in International Development Association in 1999 to that in 2004?
Keep it short and to the point. 0.67. What is the ratio of the Amount (in current US$) of Others in 1999 to that in 2004?
Offer a terse response. 1.11. What is the ratio of the Amount (in current US$) of Regional development banks in 1999 to that in 2005?
Make the answer very short. 0.38. What is the ratio of the Amount (in current US$) of International Development Association in 1999 to that in 2005?
Make the answer very short. 0.45. What is the ratio of the Amount (in current US$) in Others in 1999 to that in 2005?
Offer a terse response. 0.62. What is the ratio of the Amount (in current US$) in Regional development banks in 2000 to that in 2001?
Your answer should be compact. 1.01. What is the ratio of the Amount (in current US$) in International Development Association in 2000 to that in 2001?
Offer a very short reply. 0.65. What is the ratio of the Amount (in current US$) of Others in 2000 to that in 2001?
Your answer should be very brief. 1.07. What is the ratio of the Amount (in current US$) of Regional development banks in 2000 to that in 2002?
Your response must be concise. 0.47. What is the ratio of the Amount (in current US$) in International Development Association in 2000 to that in 2002?
Your answer should be compact. 0.48. What is the ratio of the Amount (in current US$) in Others in 2000 to that in 2002?
Your response must be concise. 2.11. What is the ratio of the Amount (in current US$) of Regional development banks in 2000 to that in 2003?
Your answer should be very brief. 0.14. What is the ratio of the Amount (in current US$) in International Development Association in 2000 to that in 2003?
Provide a short and direct response. 0.47. What is the ratio of the Amount (in current US$) of Others in 2000 to that in 2003?
Ensure brevity in your answer.  0.75. What is the ratio of the Amount (in current US$) in Regional development banks in 2000 to that in 2004?
Offer a terse response. 0.15. What is the ratio of the Amount (in current US$) of International Development Association in 2000 to that in 2004?
Make the answer very short. 0.61. What is the ratio of the Amount (in current US$) in Others in 2000 to that in 2004?
Your answer should be compact. 0.92. What is the ratio of the Amount (in current US$) in Regional development banks in 2000 to that in 2005?
Keep it short and to the point. 0.11. What is the ratio of the Amount (in current US$) in International Development Association in 2000 to that in 2005?
Ensure brevity in your answer.  0.41. What is the ratio of the Amount (in current US$) in Others in 2000 to that in 2005?
Provide a succinct answer. 0.51. What is the ratio of the Amount (in current US$) in Regional development banks in 2001 to that in 2002?
Provide a short and direct response. 0.46. What is the ratio of the Amount (in current US$) of International Development Association in 2001 to that in 2002?
Offer a terse response. 0.74. What is the ratio of the Amount (in current US$) of Others in 2001 to that in 2002?
Provide a short and direct response. 1.97. What is the ratio of the Amount (in current US$) in Regional development banks in 2001 to that in 2003?
Ensure brevity in your answer.  0.14. What is the ratio of the Amount (in current US$) of International Development Association in 2001 to that in 2003?
Give a very brief answer. 0.72. What is the ratio of the Amount (in current US$) in Others in 2001 to that in 2003?
Give a very brief answer. 0.7. What is the ratio of the Amount (in current US$) in Regional development banks in 2001 to that in 2004?
Ensure brevity in your answer.  0.15. What is the ratio of the Amount (in current US$) of International Development Association in 2001 to that in 2004?
Make the answer very short. 0.94. What is the ratio of the Amount (in current US$) in Others in 2001 to that in 2004?
Your answer should be very brief. 0.86. What is the ratio of the Amount (in current US$) of Regional development banks in 2001 to that in 2005?
Make the answer very short. 0.11. What is the ratio of the Amount (in current US$) in International Development Association in 2001 to that in 2005?
Provide a short and direct response. 0.63. What is the ratio of the Amount (in current US$) of Others in 2001 to that in 2005?
Ensure brevity in your answer.  0.48. What is the ratio of the Amount (in current US$) in Regional development banks in 2002 to that in 2003?
Your response must be concise. 0.3. What is the ratio of the Amount (in current US$) of International Development Association in 2002 to that in 2003?
Keep it short and to the point. 0.97. What is the ratio of the Amount (in current US$) of Others in 2002 to that in 2003?
Your answer should be compact. 0.35. What is the ratio of the Amount (in current US$) in Regional development banks in 2002 to that in 2004?
Provide a succinct answer. 0.32. What is the ratio of the Amount (in current US$) in International Development Association in 2002 to that in 2004?
Offer a terse response. 1.27. What is the ratio of the Amount (in current US$) of Others in 2002 to that in 2004?
Provide a short and direct response. 0.44. What is the ratio of the Amount (in current US$) in Regional development banks in 2002 to that in 2005?
Give a very brief answer. 0.24. What is the ratio of the Amount (in current US$) in International Development Association in 2002 to that in 2005?
Give a very brief answer. 0.86. What is the ratio of the Amount (in current US$) of Others in 2002 to that in 2005?
Give a very brief answer. 0.24. What is the ratio of the Amount (in current US$) of Regional development banks in 2003 to that in 2004?
Give a very brief answer. 1.08. What is the ratio of the Amount (in current US$) in International Development Association in 2003 to that in 2004?
Your answer should be very brief. 1.31. What is the ratio of the Amount (in current US$) of Others in 2003 to that in 2004?
Make the answer very short. 1.23. What is the ratio of the Amount (in current US$) of Regional development banks in 2003 to that in 2005?
Your answer should be very brief. 0.78. What is the ratio of the Amount (in current US$) in International Development Association in 2003 to that in 2005?
Your answer should be very brief. 0.89. What is the ratio of the Amount (in current US$) in Others in 2003 to that in 2005?
Your response must be concise. 0.68. What is the ratio of the Amount (in current US$) of Regional development banks in 2004 to that in 2005?
Your answer should be compact. 0.72. What is the ratio of the Amount (in current US$) in International Development Association in 2004 to that in 2005?
Your answer should be compact. 0.68. What is the ratio of the Amount (in current US$) of Others in 2004 to that in 2005?
Provide a succinct answer. 0.55. What is the difference between the highest and the second highest Amount (in current US$) in Regional development banks?
Your response must be concise. 1.15e+07. What is the difference between the highest and the second highest Amount (in current US$) of International Monetary Fund?
Make the answer very short. 9.83e+06. What is the difference between the highest and the second highest Amount (in current US$) in International Development Association?
Offer a very short reply. 1.17e+07. What is the difference between the highest and the second highest Amount (in current US$) of Others?
Offer a very short reply. 7.19e+06. What is the difference between the highest and the lowest Amount (in current US$) of Regional development banks?
Keep it short and to the point. 4.70e+07. What is the difference between the highest and the lowest Amount (in current US$) of International Monetary Fund?
Make the answer very short. 2.15e+07. What is the difference between the highest and the lowest Amount (in current US$) of International Development Association?
Make the answer very short. 6.30e+07. What is the difference between the highest and the lowest Amount (in current US$) in Others?
Give a very brief answer. 1.72e+07. 